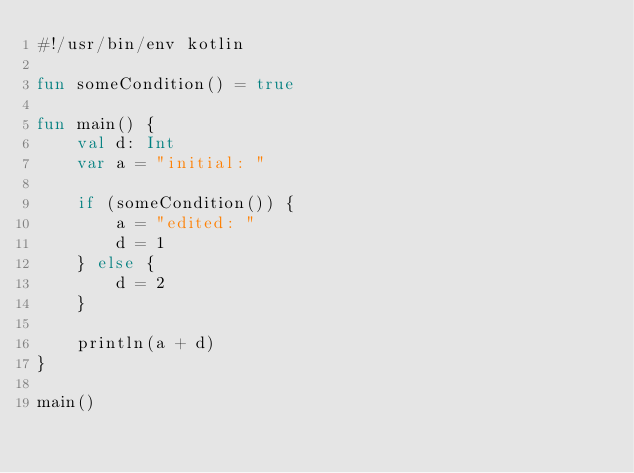<code> <loc_0><loc_0><loc_500><loc_500><_Kotlin_>#!/usr/bin/env kotlin

fun someCondition() = true

fun main() {
    val d: Int
    var a = "initial: "

    if (someCondition()) {
        a = "edited: "
        d = 1
    } else {
        d = 2
    }

    println(a + d)
}

main()
</code> 